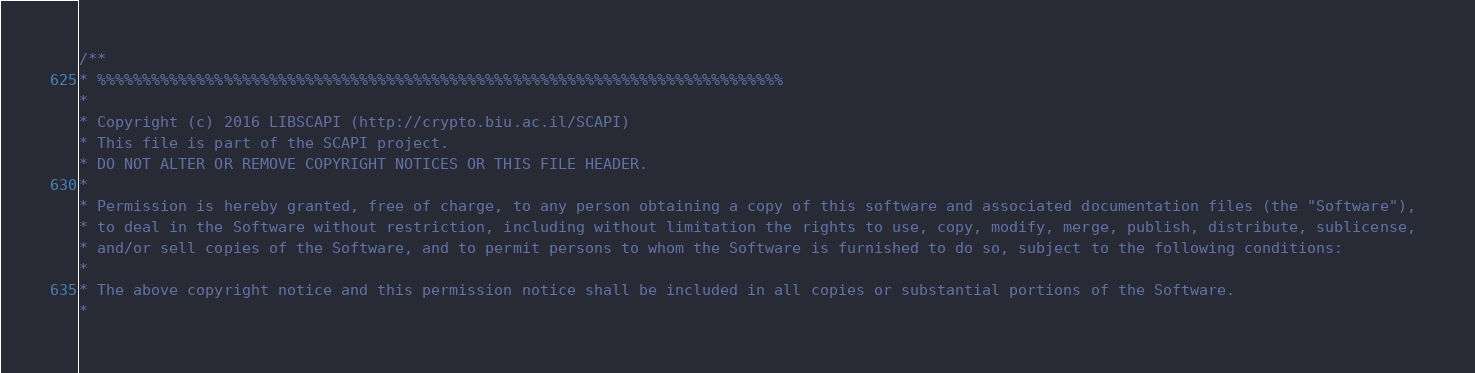Convert code to text. <code><loc_0><loc_0><loc_500><loc_500><_C++_>/**
* %%%%%%%%%%%%%%%%%%%%%%%%%%%%%%%%%%%%%%%%%%%%%%%%%%%%%%%%%%%%%%%%%%%%%%%%%%%%
* 
* Copyright (c) 2016 LIBSCAPI (http://crypto.biu.ac.il/SCAPI)
* This file is part of the SCAPI project.
* DO NOT ALTER OR REMOVE COPYRIGHT NOTICES OR THIS FILE HEADER.
* 
* Permission is hereby granted, free of charge, to any person obtaining a copy of this software and associated documentation files (the "Software"),
* to deal in the Software without restriction, including without limitation the rights to use, copy, modify, merge, publish, distribute, sublicense, 
* and/or sell copies of the Software, and to permit persons to whom the Software is furnished to do so, subject to the following conditions:
* 
* The above copyright notice and this permission notice shall be included in all copies or substantial portions of the Software.
* </code> 